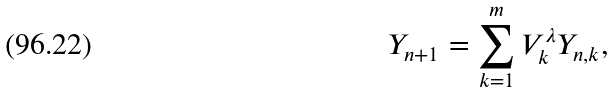Convert formula to latex. <formula><loc_0><loc_0><loc_500><loc_500>Y _ { n + 1 } = \sum _ { k = 1 } ^ { m } V _ { k } ^ { \lambda } Y _ { n , k } ,</formula> 